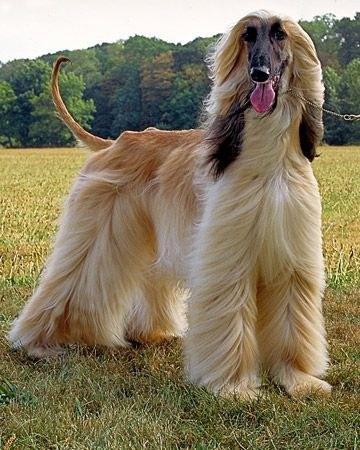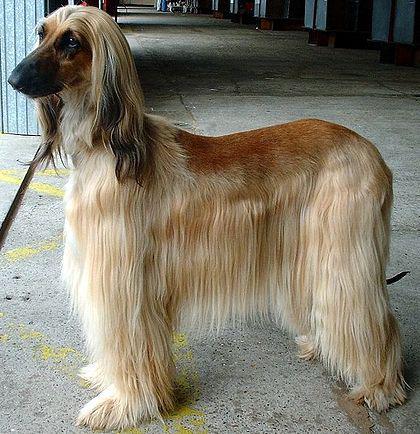The first image is the image on the left, the second image is the image on the right. Examine the images to the left and right. Is the description "One of the dogs has braided hair." accurate? Answer yes or no. No. The first image is the image on the left, the second image is the image on the right. Assess this claim about the two images: "In at least one image there is a single dog with bangs the cover part of one eye.". Correct or not? Answer yes or no. No. 